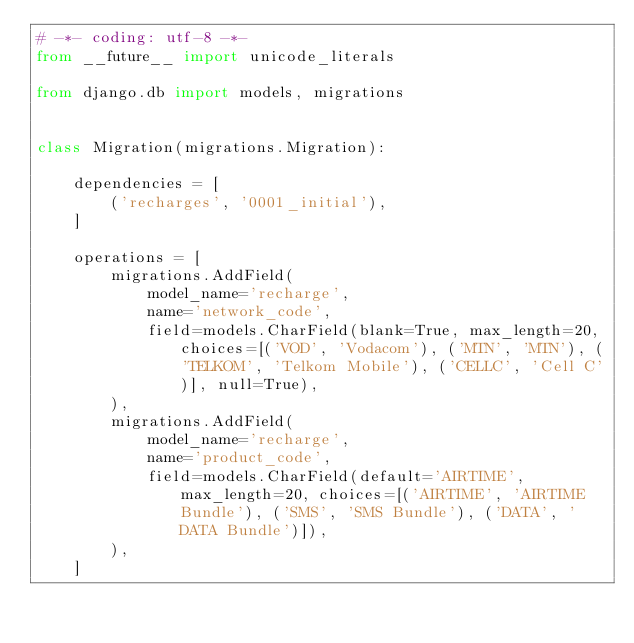Convert code to text. <code><loc_0><loc_0><loc_500><loc_500><_Python_># -*- coding: utf-8 -*-
from __future__ import unicode_literals

from django.db import models, migrations


class Migration(migrations.Migration):

    dependencies = [
        ('recharges', '0001_initial'),
    ]

    operations = [
        migrations.AddField(
            model_name='recharge',
            name='network_code',
            field=models.CharField(blank=True, max_length=20, choices=[('VOD', 'Vodacom'), ('MTN', 'MTN'), ('TELKOM', 'Telkom Mobile'), ('CELLC', 'Cell C')], null=True),
        ),
        migrations.AddField(
            model_name='recharge',
            name='product_code',
            field=models.CharField(default='AIRTIME', max_length=20, choices=[('AIRTIME', 'AIRTIME Bundle'), ('SMS', 'SMS Bundle'), ('DATA', 'DATA Bundle')]),
        ),
    ]
</code> 